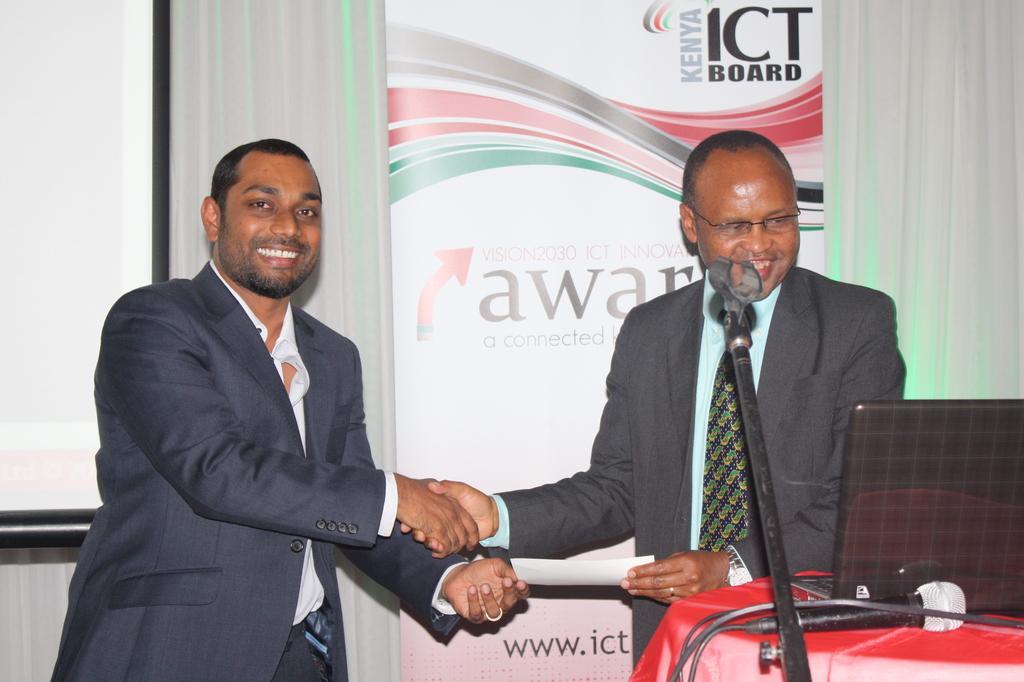How would you summarize this image in a sentence or two? In this picture we can see two men wore blazers and standing and shaking hands and smiling and in front of them we can see a paper, laptop and a mic on the table and at the back of them we can see a poster, curtains. 